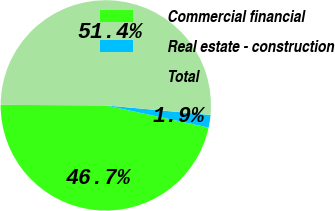Convert chart. <chart><loc_0><loc_0><loc_500><loc_500><pie_chart><fcel>Commercial financial<fcel>Real estate - construction<fcel>Total<nl><fcel>46.7%<fcel>1.93%<fcel>51.37%<nl></chart> 